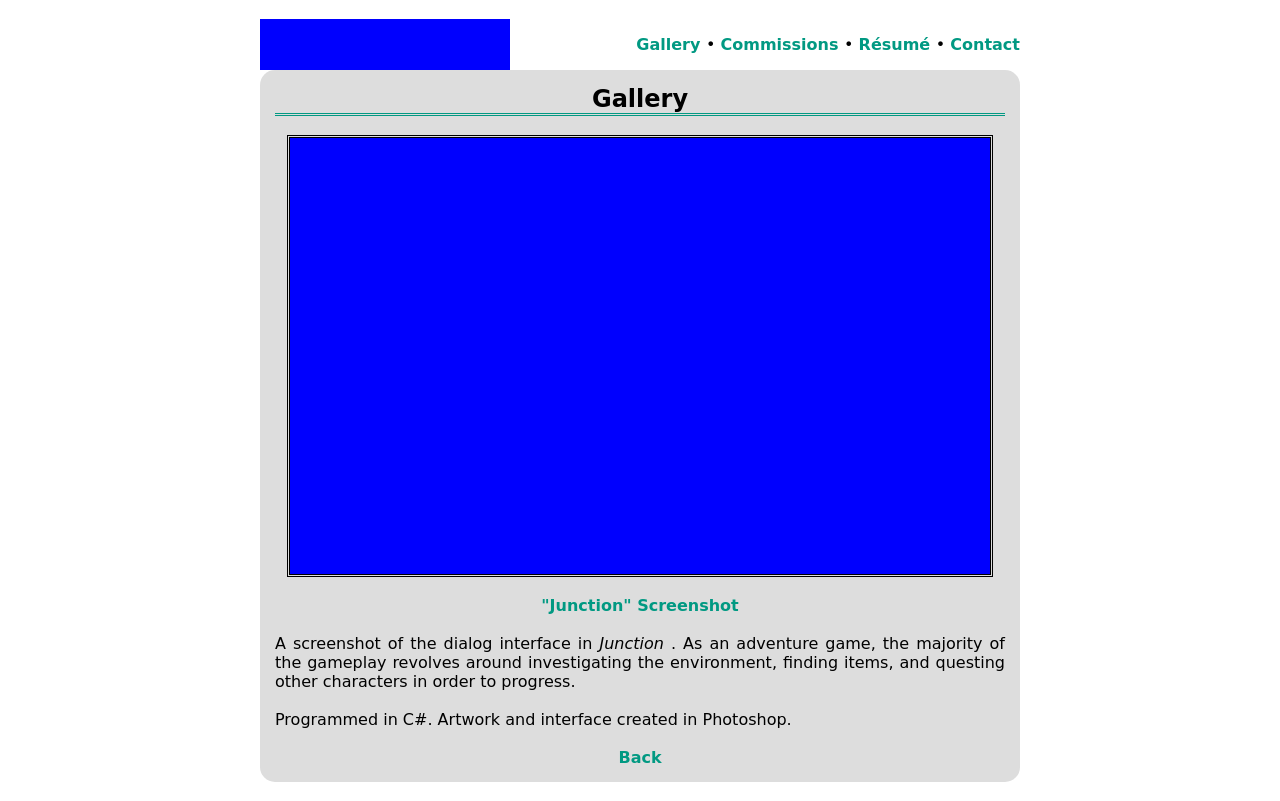What is the main theme of the screenshot from 'Junction' shown in the image? The main theme of the screenshot from 'Junction' appears to focus on dialog-driven gameplay typical of adventure games. The interface suggests significant interaction with story elements and characters, emphasized by dialog boxes and minimalistic design, which keeps the player focused on the narrative and choices. 